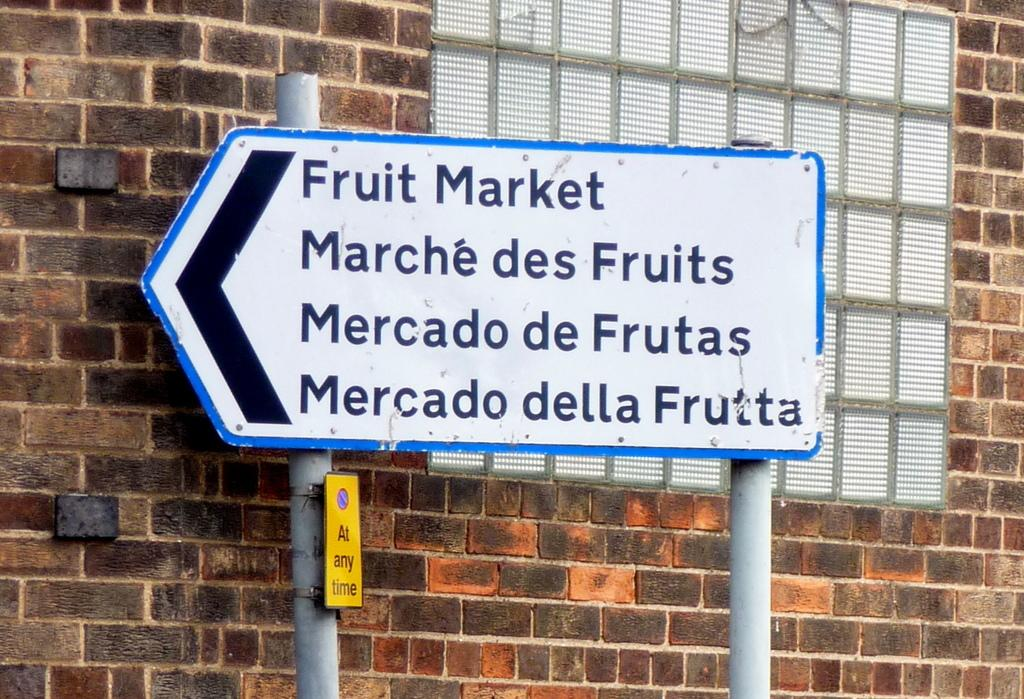<image>
Relay a brief, clear account of the picture shown. A sign hung against a brick wall shows the way to the fruit market. 